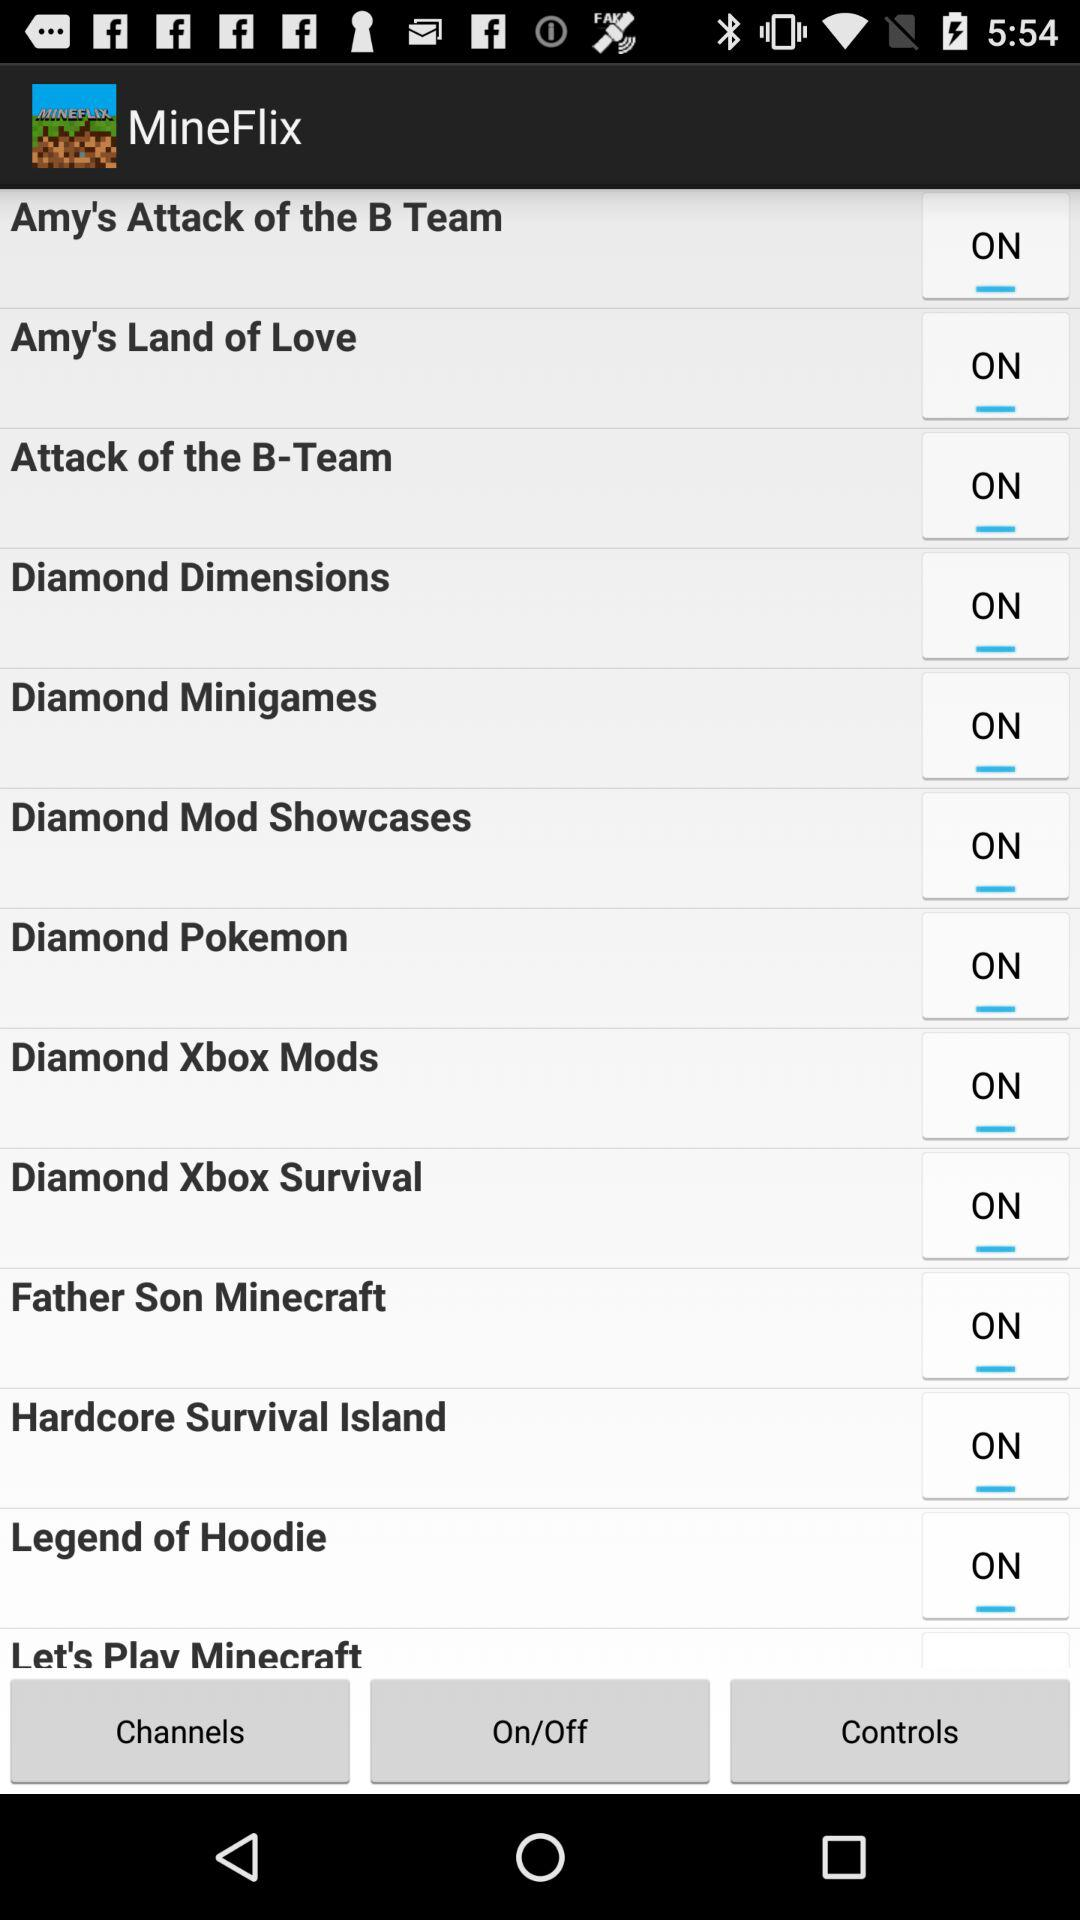What is the current status of "Diamond Minigames"? The current status of "Diamond Minigames" is "on". 